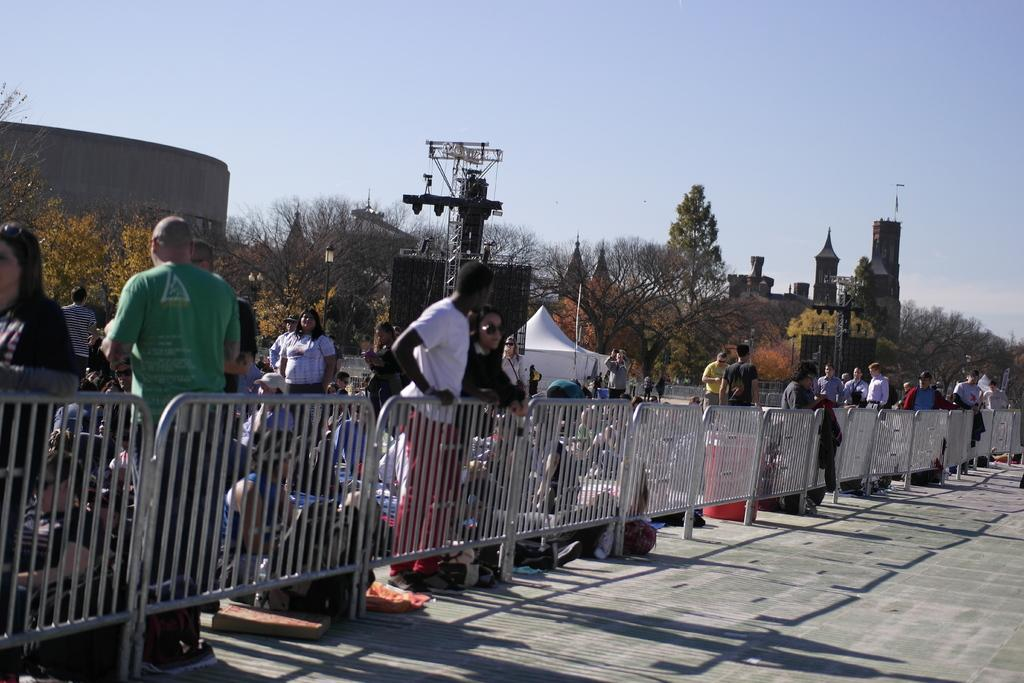What is the main structure visible in the image? There is a fencing in the image. What is located behind the fencing? There are a lot of people behind the fencing. What type of natural environment is visible behind the people? There are plenty of trees behind the people. What type of man-made structures can be seen in the image? There are buildings visible in the image. What other objects can be seen in the image? There are poles in the image. What type of mask is being worn by the person in the image? There is no person wearing a mask in the image. What is the position of the person in the image? There is no person present in the image, so their position cannot be determined. 